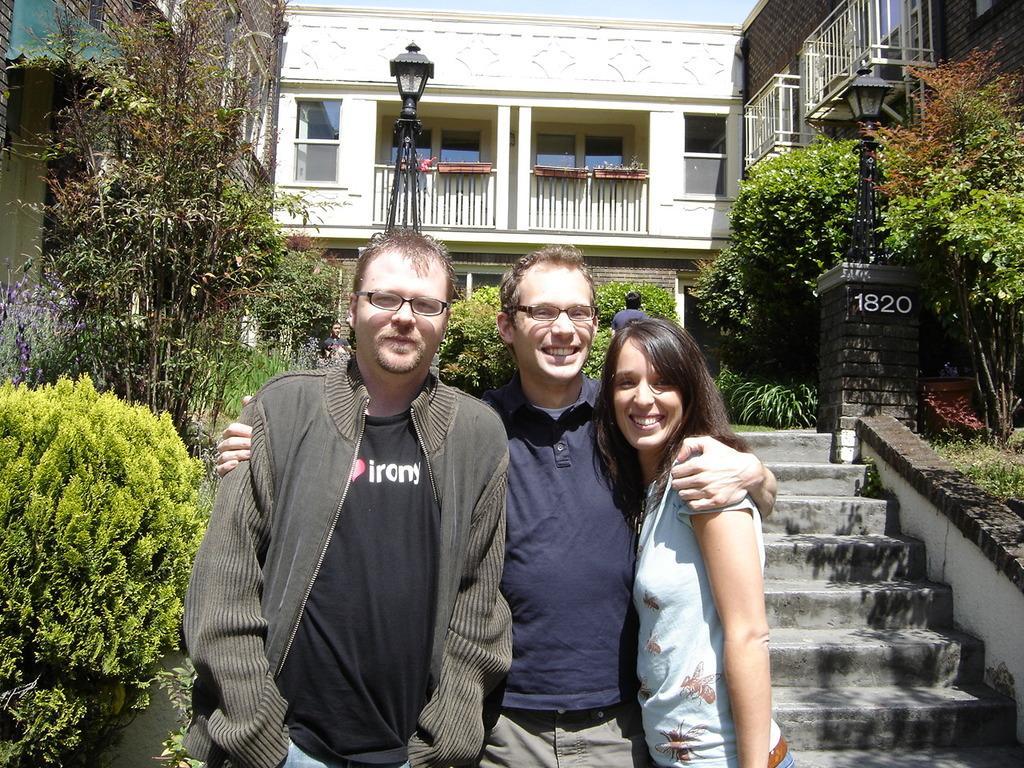How would you summarize this image in a sentence or two? In this image in the foreground three persons are standing. In the right a lady is there. They all are smiling. This is the staircase. Here there is another person. On both sides there are plants. In the background there are buildings, trees. Here there are lamps. The sky is clear. 